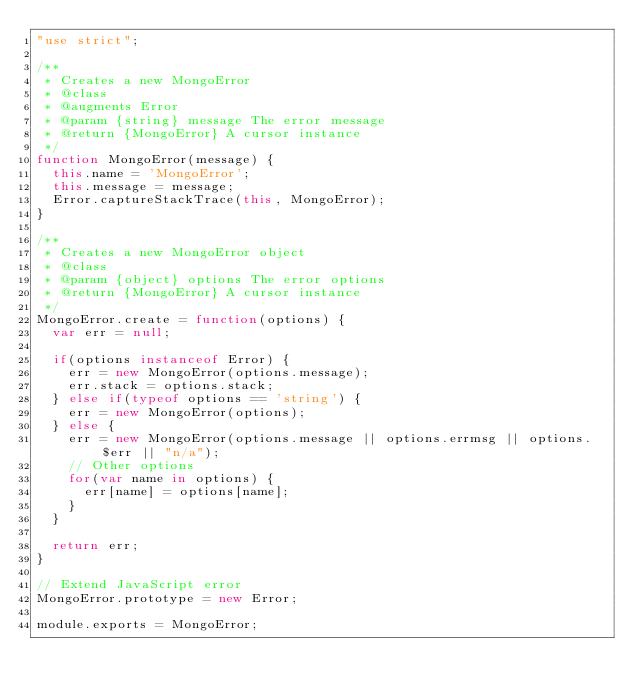Convert code to text. <code><loc_0><loc_0><loc_500><loc_500><_JavaScript_>"use strict";

/**
 * Creates a new MongoError
 * @class
 * @augments Error
 * @param {string} message The error message
 * @return {MongoError} A cursor instance
 */
function MongoError(message) {
  this.name = 'MongoError';
  this.message = message;
  Error.captureStackTrace(this, MongoError);
}

/**
 * Creates a new MongoError object
 * @class
 * @param {object} options The error options
 * @return {MongoError} A cursor instance
 */
MongoError.create = function(options) {
  var err = null;

  if(options instanceof Error) {
    err = new MongoError(options.message);
    err.stack = options.stack;
  } else if(typeof options == 'string') {
    err = new MongoError(options);
  } else {
    err = new MongoError(options.message || options.errmsg || options.$err || "n/a");
    // Other options
    for(var name in options) {
      err[name] = options[name];
    }
  }

  return err;
}

// Extend JavaScript error
MongoError.prototype = new Error; 

module.exports = MongoError;
</code> 